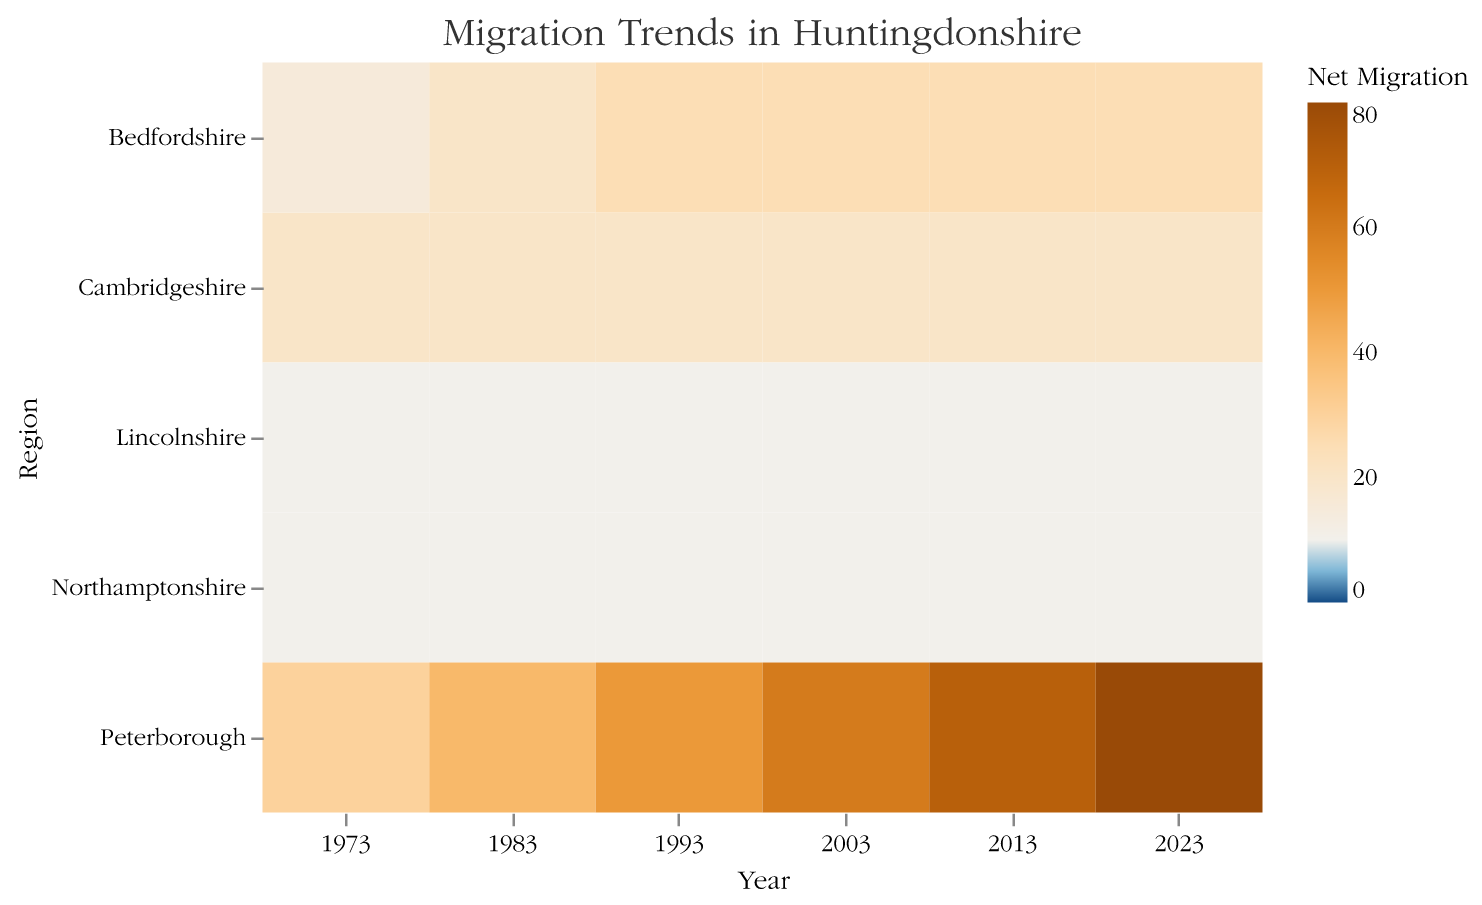Which region had the highest net migration in 2023? Look at the color intensity for the year 2023 and compare all the regions. The darkest blue shade indicates the highest net migration.
Answer: Cambridgeshire Which year did Peterborough have its highest incoming population? For Peterborough, compare the incoming populations across all years by looking at the data points in the heatmap. The year with the highest intensity of blue for incoming population indicates the highest value.
Answer: 2023 What is the net migration trend for Lincolnshire from 1973 to 2023? For Lincolnshire, observe the changing color intensity from 1973 to 2023. Consistently lighter shades or transition to orange suggests lower net migration or more people leaving over time.
Answer: Increasingly positive During which year was the outgoing population from Bedfordshire the closest to its incoming population? Compare the shades of orange and blue for incoming and outgoing populations in Bedfordshire across all years. The year with colors that are closest suggests minimal net migration.
Answer: 1983 What is the average net migration in Huntingdonshire for the years 1973, 1983, and 1993 for the region of Cambridgeshire? Calculate the net migration for each of the given years and find their average. For each year, subtract the outgoing population from the incoming population, sum the results, and then divide by 3. For 1973: 200 - 180 = 20, 1983: 220 - 200 = 20, 1993: 240 - 220 = 20. The average is (20 + 20 + 20) / 3.
Answer: 20 Compare the net migration in Cambridgeshire and Peterborough for the year 2003. Which one is higher? Look at the color representing net migration for Cambridgeshire and Peterborough in the year 2003. The darkest blue indicates a higher positive migration. Calculate the exact net migration: Cambridgeshire = 260 - 240 = 20, Peterborough = 250 - 190 = 60.
Answer: Peterborough What was the outgoing population trend for Northamptonshire from 1973 to 2023? Observe the shades in the columns corresponding to outgoing population for Northamptonshire across the years. Look for consistency of color to determine if the population's trend is increasing, decreasing, or stable.
Answer: Increasing Which region experienced the most significant increase in net migration from 1973 to 2023? Compare the colors for the years 1973 and 2023 for all regions. The region with the greatest difference in color intensity (from light to dark blue) has the most notable increase.
Answer: Cambridgeshire What is the general trend in net migration for Huntingdonshire over the 50 years covered in the heatmap? Examine the overall color trend from earlier years to the latest ones. An overall shift towards darker blue shades indicates an increasing net positive migration, while orange indicates negative migration.
Answer: Increasing net positive migration 